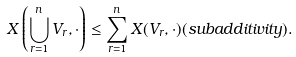Convert formula to latex. <formula><loc_0><loc_0><loc_500><loc_500>X \left ( \bigcup _ { r = 1 } ^ { n } V _ { r } , \cdot \right ) \leq \sum _ { r = 1 } ^ { n } X ( V _ { r } , \cdot ) ( s u b a d d i t i v i t y ) .</formula> 